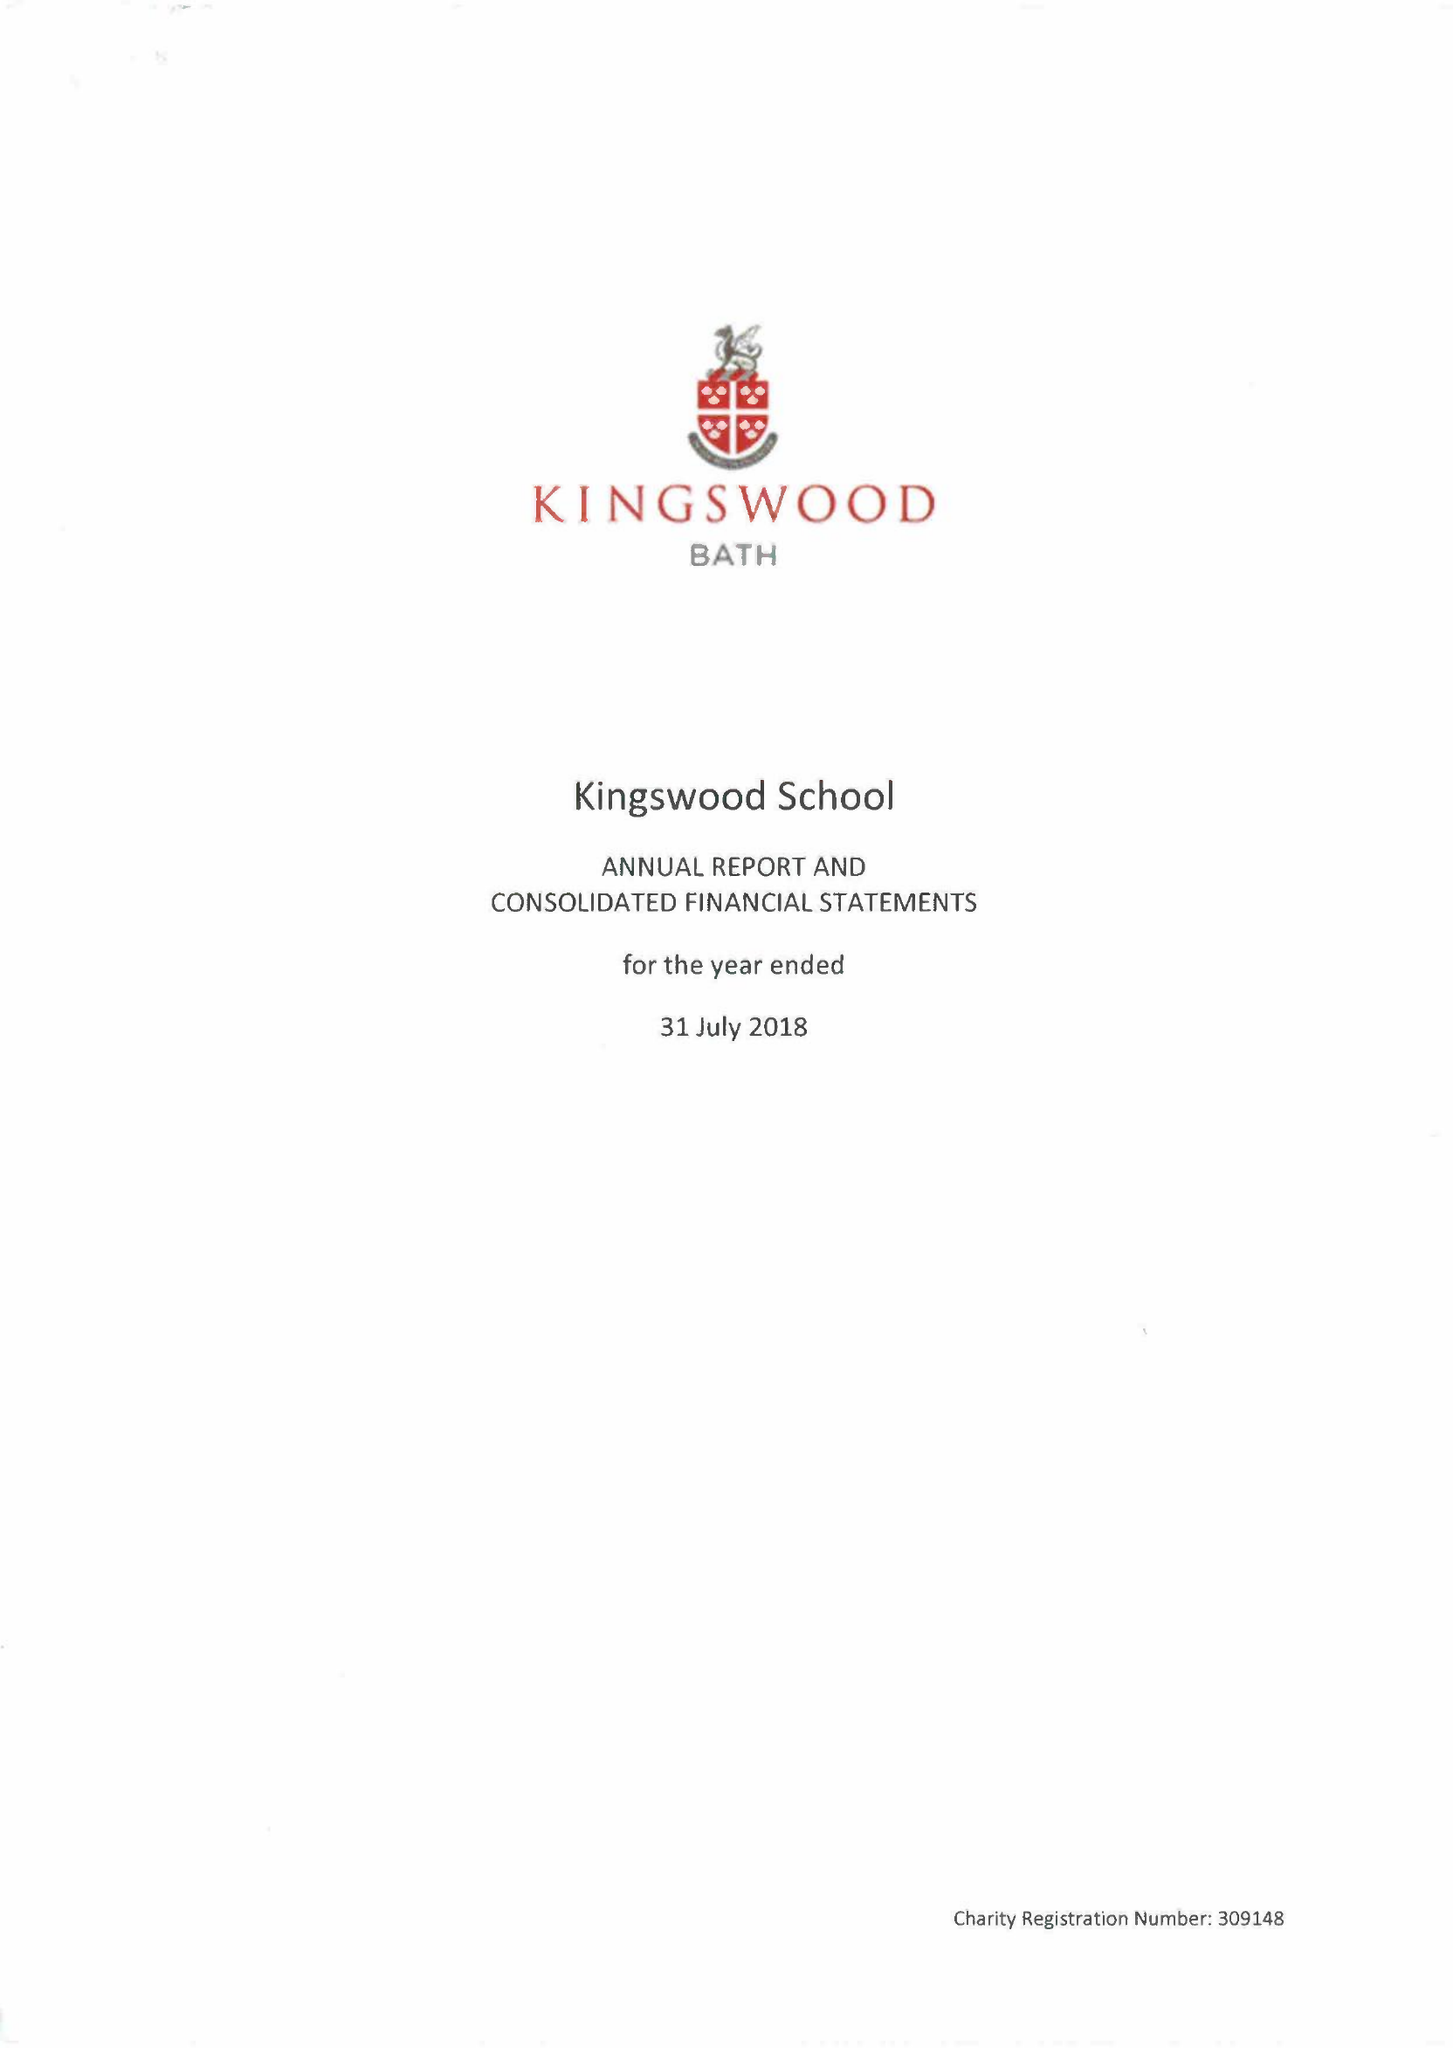What is the value for the address__postcode?
Answer the question using a single word or phrase. BA1 5RG 